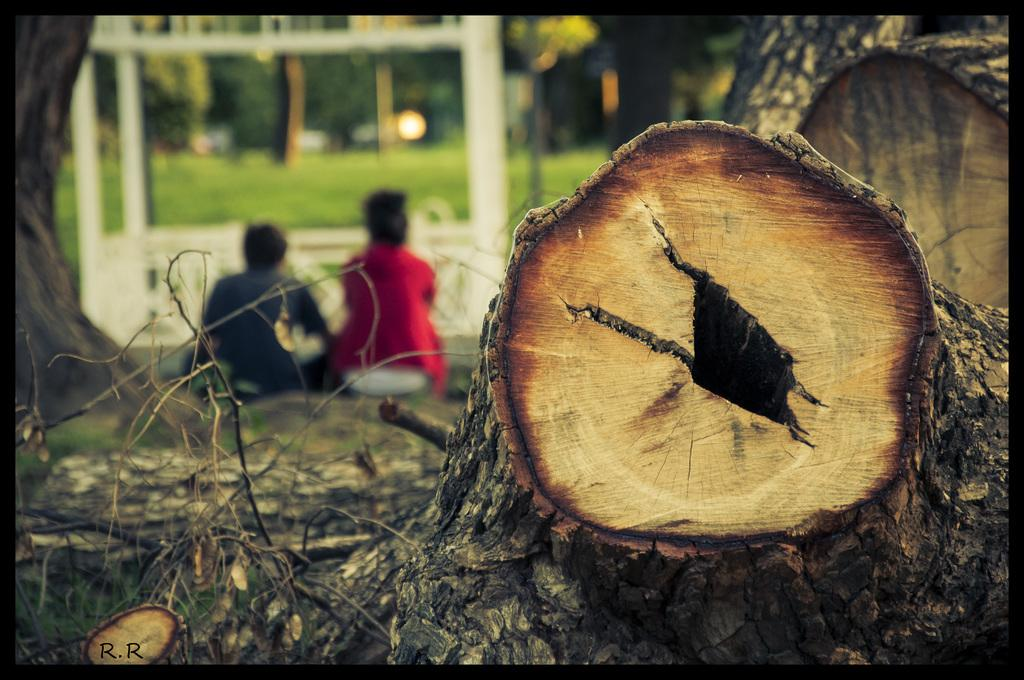How many people are present in the image? There are two persons sitting in the image. What can be seen on the left side of the image? There is a tree on the left side of the image. What type of vegetation is visible in the background of the image? Grass is visible in the background of the image. What material is present in the front of the image? There is some wood in the front of the image. What color crayon is being used by one of the persons in the image? There is no crayon present in the image, so it cannot be determined what color crayon might be used. 